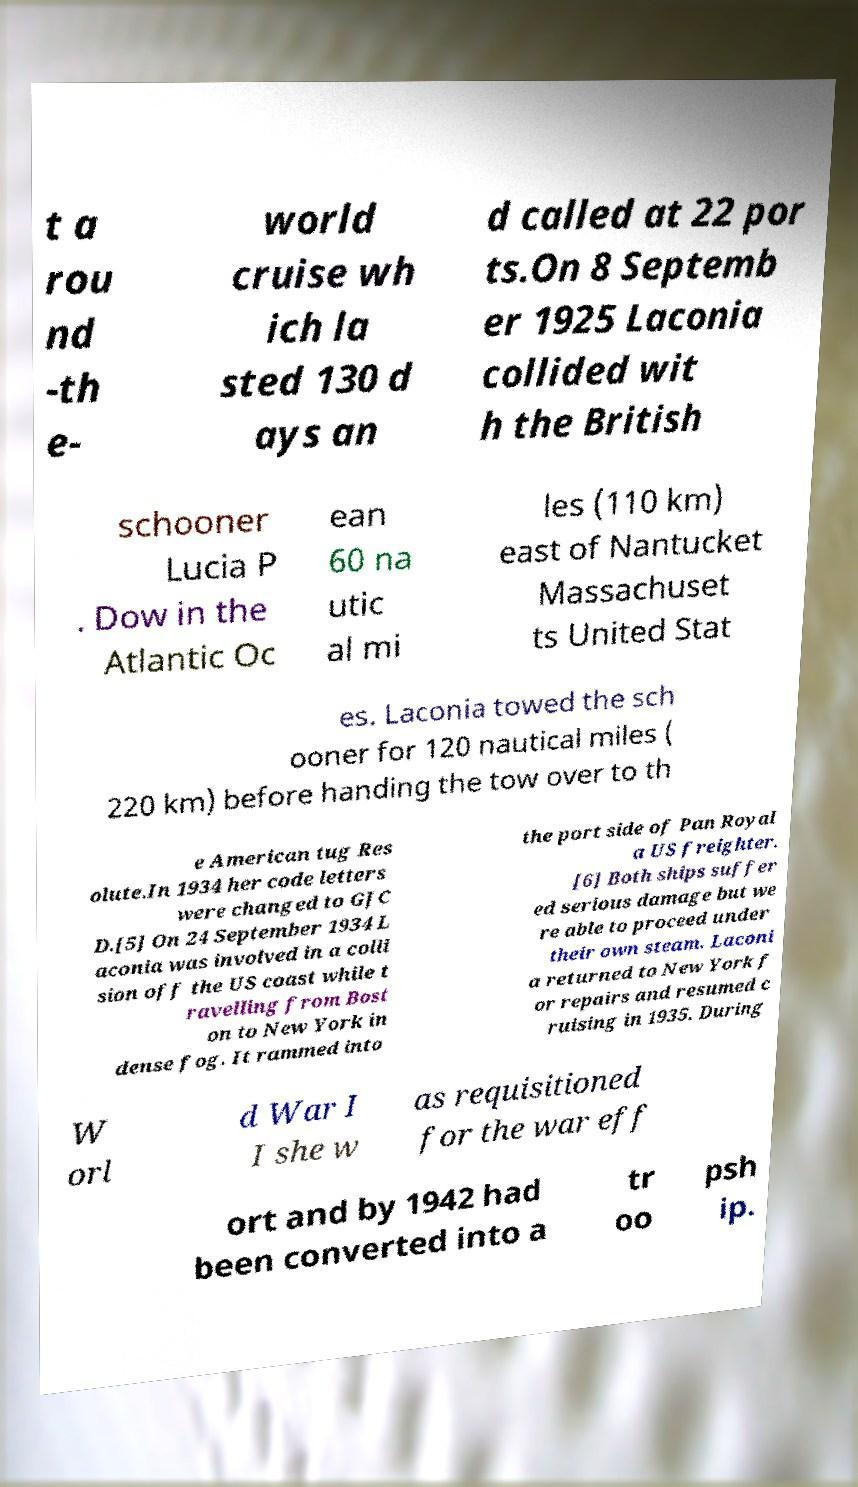Please read and relay the text visible in this image. What does it say? t a rou nd -th e- world cruise wh ich la sted 130 d ays an d called at 22 por ts.On 8 Septemb er 1925 Laconia collided wit h the British schooner Lucia P . Dow in the Atlantic Oc ean 60 na utic al mi les (110 km) east of Nantucket Massachuset ts United Stat es. Laconia towed the sch ooner for 120 nautical miles ( 220 km) before handing the tow over to th e American tug Res olute.In 1934 her code letters were changed to GJC D.[5] On 24 September 1934 L aconia was involved in a colli sion off the US coast while t ravelling from Bost on to New York in dense fog. It rammed into the port side of Pan Royal a US freighter. [6] Both ships suffer ed serious damage but we re able to proceed under their own steam. Laconi a returned to New York f or repairs and resumed c ruising in 1935. During W orl d War I I she w as requisitioned for the war eff ort and by 1942 had been converted into a tr oo psh ip. 